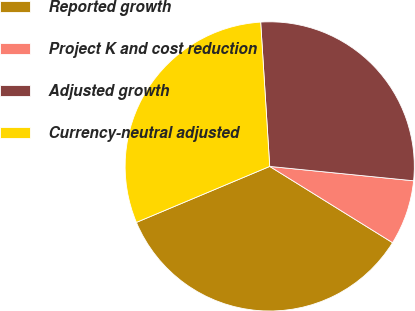<chart> <loc_0><loc_0><loc_500><loc_500><pie_chart><fcel>Reported growth<fcel>Project K and cost reduction<fcel>Adjusted growth<fcel>Currency-neutral adjusted<nl><fcel>34.83%<fcel>7.26%<fcel>27.58%<fcel>30.33%<nl></chart> 